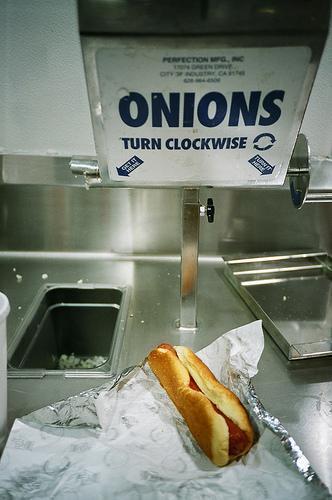How many hot dogs are there?
Give a very brief answer. 1. How many people are in the photo?
Give a very brief answer. 0. How many chicken legs are there?
Give a very brief answer. 0. How many blue arrows on the onions dispenser are pointed to the lower right?
Give a very brief answer. 1. 